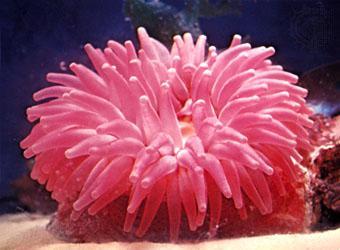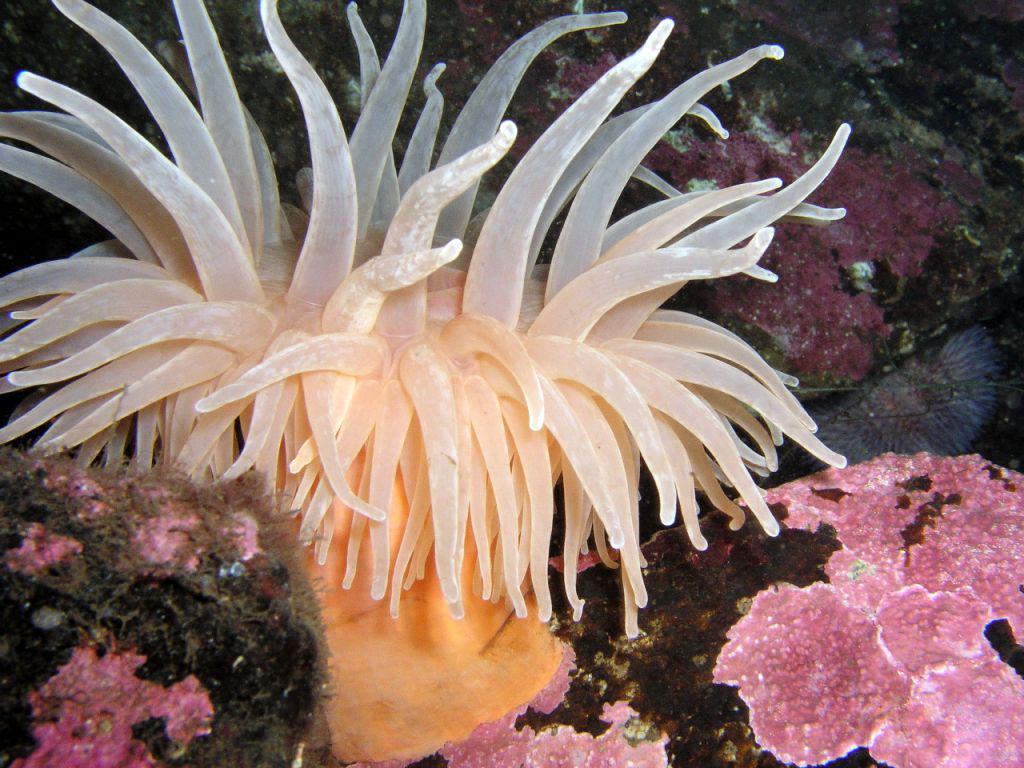The first image is the image on the left, the second image is the image on the right. Analyze the images presented: Is the assertion "One of the sea creatures is yellowish in color and the other is pink." valid? Answer yes or no. Yes. The first image is the image on the left, the second image is the image on the right. For the images shown, is this caption "An image shows an anemone with lavender tendrils that taper distinctly." true? Answer yes or no. No. 